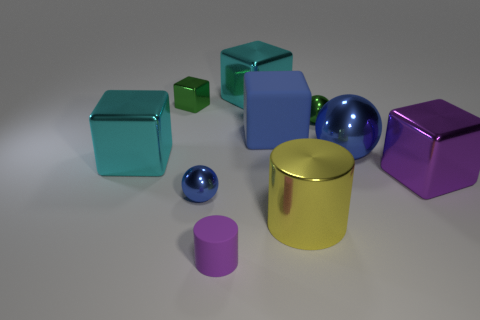What number of purple objects are the same size as the purple cube?
Give a very brief answer. 0. There is a purple thing that is in front of the small blue shiny thing; are there any yellow cylinders that are left of it?
Ensure brevity in your answer.  No. What number of things are small gray matte cubes or large yellow cylinders?
Your response must be concise. 1. What color is the metal ball left of the cyan metallic object that is behind the tiny shiny thing left of the tiny blue thing?
Keep it short and to the point. Blue. Is there any other thing that has the same color as the small cube?
Your answer should be very brief. Yes. Does the purple metallic object have the same size as the matte block?
Give a very brief answer. Yes. How many things are either large cyan blocks that are in front of the large blue metal sphere or objects that are to the right of the yellow cylinder?
Offer a terse response. 4. There is a large blue cube that is behind the purple thing that is on the left side of the big yellow cylinder; what is its material?
Ensure brevity in your answer.  Rubber. How many other things are there of the same material as the big purple object?
Make the answer very short. 7. Is the large yellow metal thing the same shape as the small matte object?
Provide a succinct answer. Yes. 